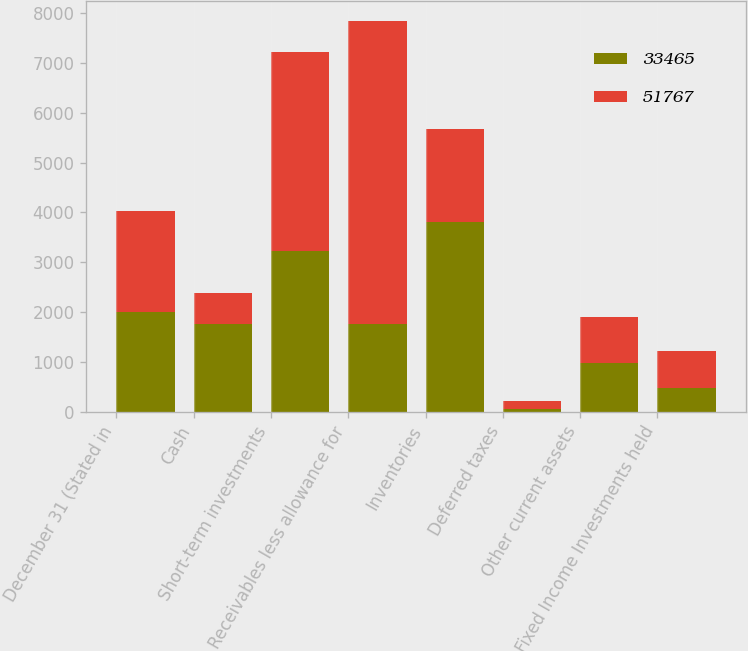Convert chart. <chart><loc_0><loc_0><loc_500><loc_500><stacked_bar_chart><ecel><fcel>December 31 (Stated in<fcel>Cash<fcel>Short-term investments<fcel>Receivables less allowance for<fcel>Inventories<fcel>Deferred taxes<fcel>Other current assets<fcel>Fixed Income Investments held<nl><fcel>33465<fcel>2010<fcel>1764<fcel>3226<fcel>1764<fcel>3804<fcel>51<fcel>975<fcel>484<nl><fcel>51767<fcel>2009<fcel>617<fcel>3999<fcel>6088<fcel>1866<fcel>154<fcel>926<fcel>738<nl></chart> 